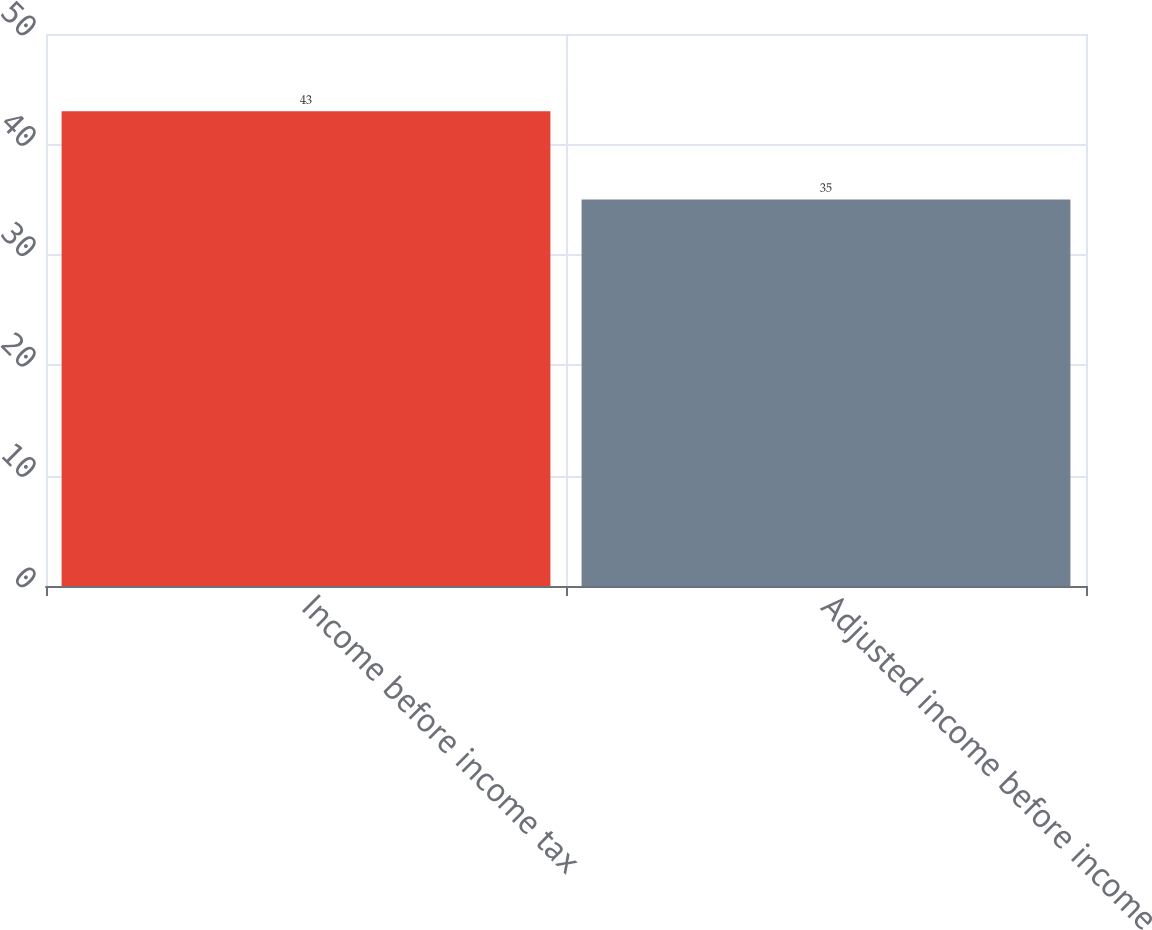<chart> <loc_0><loc_0><loc_500><loc_500><bar_chart><fcel>Income before income tax<fcel>Adjusted income before income<nl><fcel>43<fcel>35<nl></chart> 